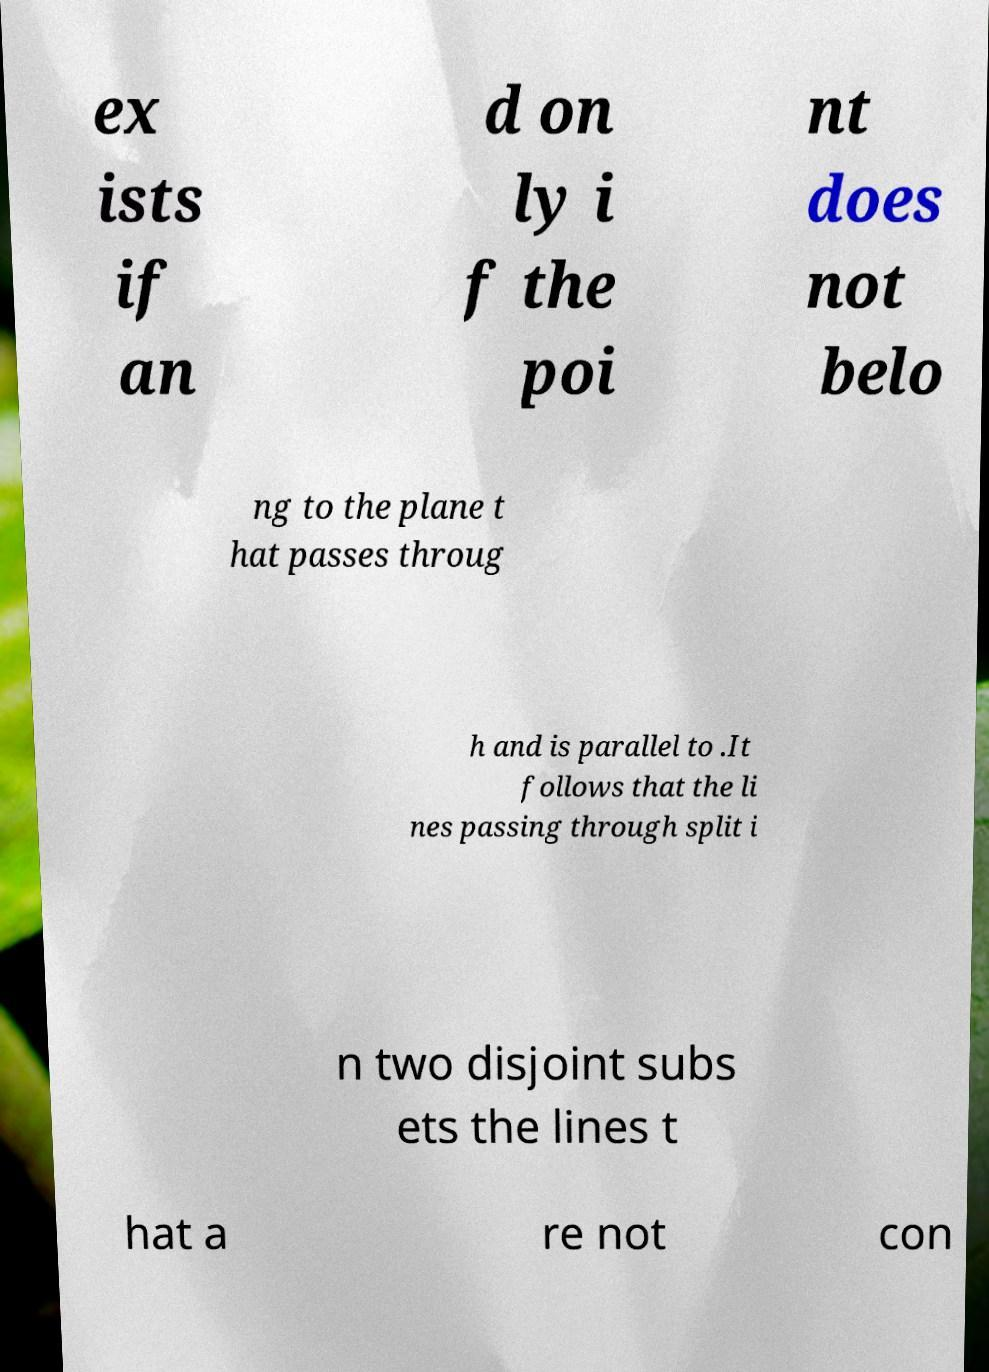Please read and relay the text visible in this image. What does it say? ex ists if an d on ly i f the poi nt does not belo ng to the plane t hat passes throug h and is parallel to .It follows that the li nes passing through split i n two disjoint subs ets the lines t hat a re not con 